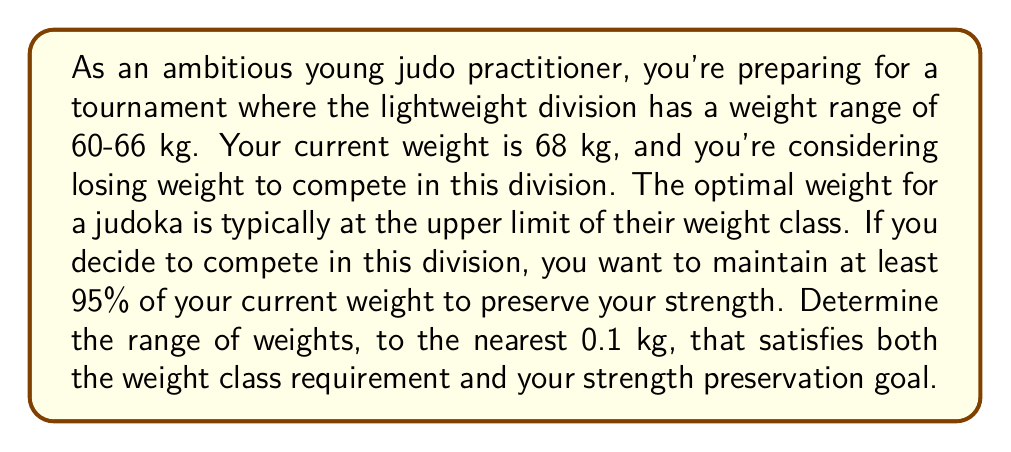Show me your answer to this math problem. Let's approach this step-by-step:

1) First, we need to determine the lower bound of your weight range. This is the maximum of two constraints:
   a) The lower limit of the weight class: 60 kg
   b) 95% of your current weight: $0.95 \times 68 = 64.6$ kg

   $\max(60, 64.6) = 64.6$ kg

2) The upper bound is simply the upper limit of the weight class: 66 kg

3) Therefore, your weight range should be $[64.6, 66]$ kg

4) Rounding to the nearest 0.1 kg:
   Lower bound: 64.6 kg (already to nearest 0.1)
   Upper bound: 66.0 kg

The inequality representing this range is:

$$64.6 \leq x \leq 66.0$$

where $x$ represents your weight in kilograms.
Answer: The optimal weight range is $[64.6, 66.0]$ kg. 